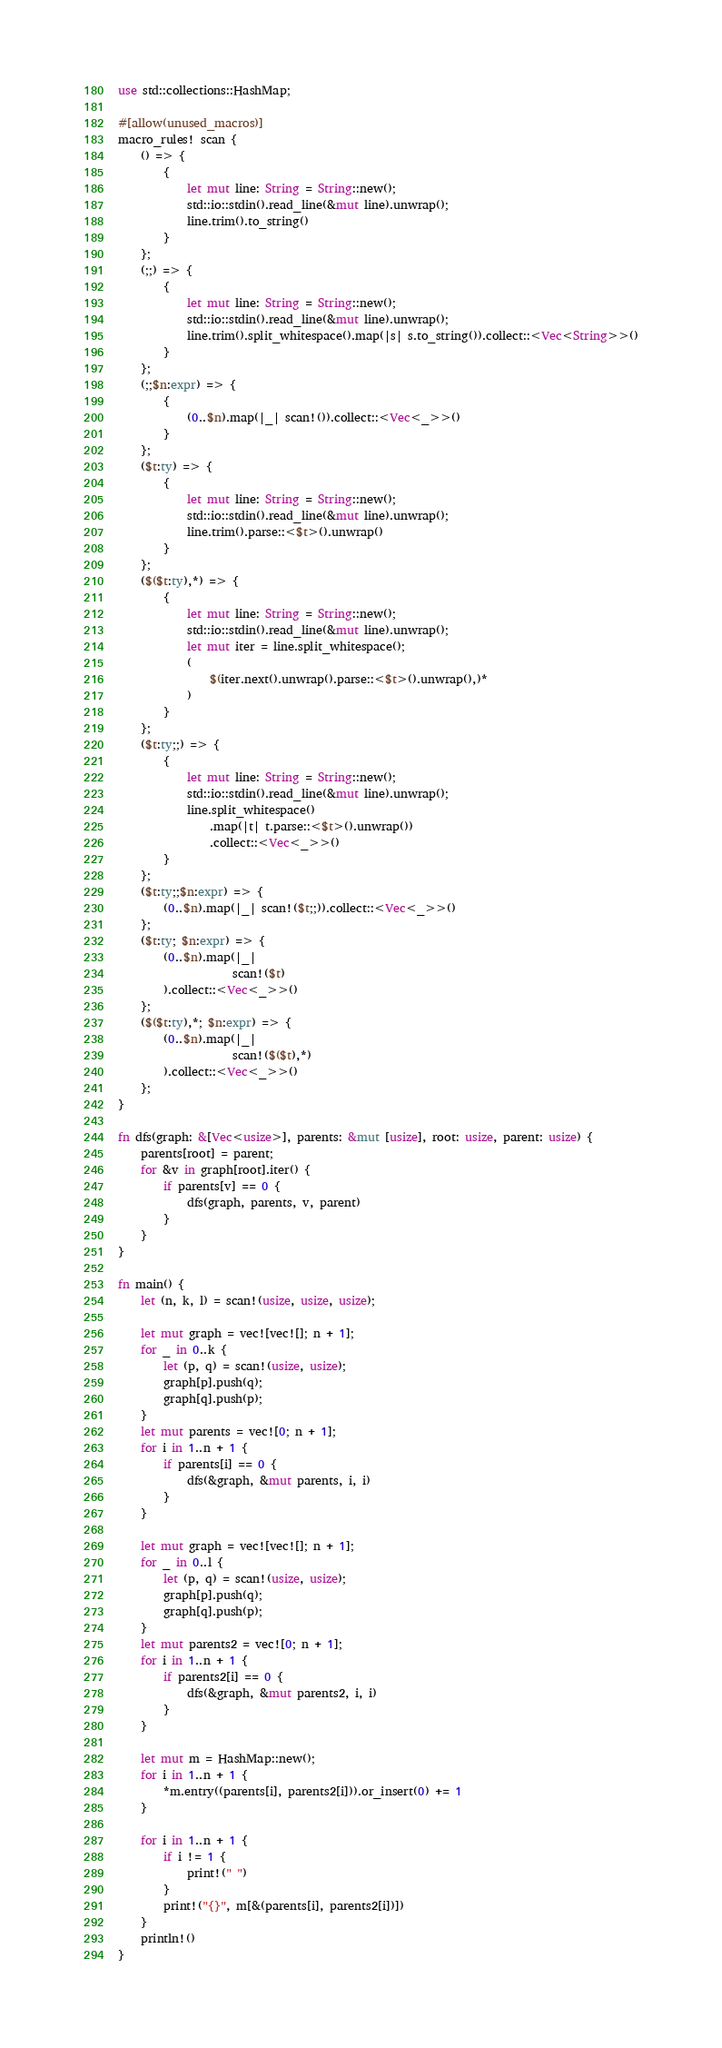Convert code to text. <code><loc_0><loc_0><loc_500><loc_500><_Rust_>use std::collections::HashMap;

#[allow(unused_macros)]
macro_rules! scan {
    () => {
        {
            let mut line: String = String::new();
            std::io::stdin().read_line(&mut line).unwrap();
            line.trim().to_string()
        }
    };
    (;;) => {
        {
            let mut line: String = String::new();
            std::io::stdin().read_line(&mut line).unwrap();
            line.trim().split_whitespace().map(|s| s.to_string()).collect::<Vec<String>>()
        }
    };
    (;;$n:expr) => {
        {
            (0..$n).map(|_| scan!()).collect::<Vec<_>>()
        }
    };
    ($t:ty) => {
        {
            let mut line: String = String::new();
            std::io::stdin().read_line(&mut line).unwrap();
            line.trim().parse::<$t>().unwrap()
        }
    };
    ($($t:ty),*) => {
        {
            let mut line: String = String::new();
            std::io::stdin().read_line(&mut line).unwrap();
            let mut iter = line.split_whitespace();
            (
                $(iter.next().unwrap().parse::<$t>().unwrap(),)*
            )
        }
    };
    ($t:ty;;) => {
        {
            let mut line: String = String::new();
            std::io::stdin().read_line(&mut line).unwrap();
            line.split_whitespace()
                .map(|t| t.parse::<$t>().unwrap())
                .collect::<Vec<_>>()
        }
    };
    ($t:ty;;$n:expr) => {
        (0..$n).map(|_| scan!($t;;)).collect::<Vec<_>>()
    };
    ($t:ty; $n:expr) => {
        (0..$n).map(|_|
                    scan!($t)
        ).collect::<Vec<_>>()
    };
    ($($t:ty),*; $n:expr) => {
        (0..$n).map(|_|
                    scan!($($t),*)
        ).collect::<Vec<_>>()
    };
}

fn dfs(graph: &[Vec<usize>], parents: &mut [usize], root: usize, parent: usize) {
    parents[root] = parent;
    for &v in graph[root].iter() {
        if parents[v] == 0 {
            dfs(graph, parents, v, parent)
        }
    }
}

fn main() {
    let (n, k, l) = scan!(usize, usize, usize);

    let mut graph = vec![vec![]; n + 1];
    for _ in 0..k {
        let (p, q) = scan!(usize, usize);
        graph[p].push(q);
        graph[q].push(p);
    }
    let mut parents = vec![0; n + 1];
    for i in 1..n + 1 {
        if parents[i] == 0 {
            dfs(&graph, &mut parents, i, i)
        }
    }

    let mut graph = vec![vec![]; n + 1];
    for _ in 0..l {
        let (p, q) = scan!(usize, usize);
        graph[p].push(q);
        graph[q].push(p);
    }
    let mut parents2 = vec![0; n + 1];
    for i in 1..n + 1 {
        if parents2[i] == 0 {
            dfs(&graph, &mut parents2, i, i)
        }
    }

    let mut m = HashMap::new();
    for i in 1..n + 1 {
        *m.entry((parents[i], parents2[i])).or_insert(0) += 1
    }

    for i in 1..n + 1 {
        if i != 1 {
            print!(" ")
        }
        print!("{}", m[&(parents[i], parents2[i])])
    }
    println!()
}
</code> 